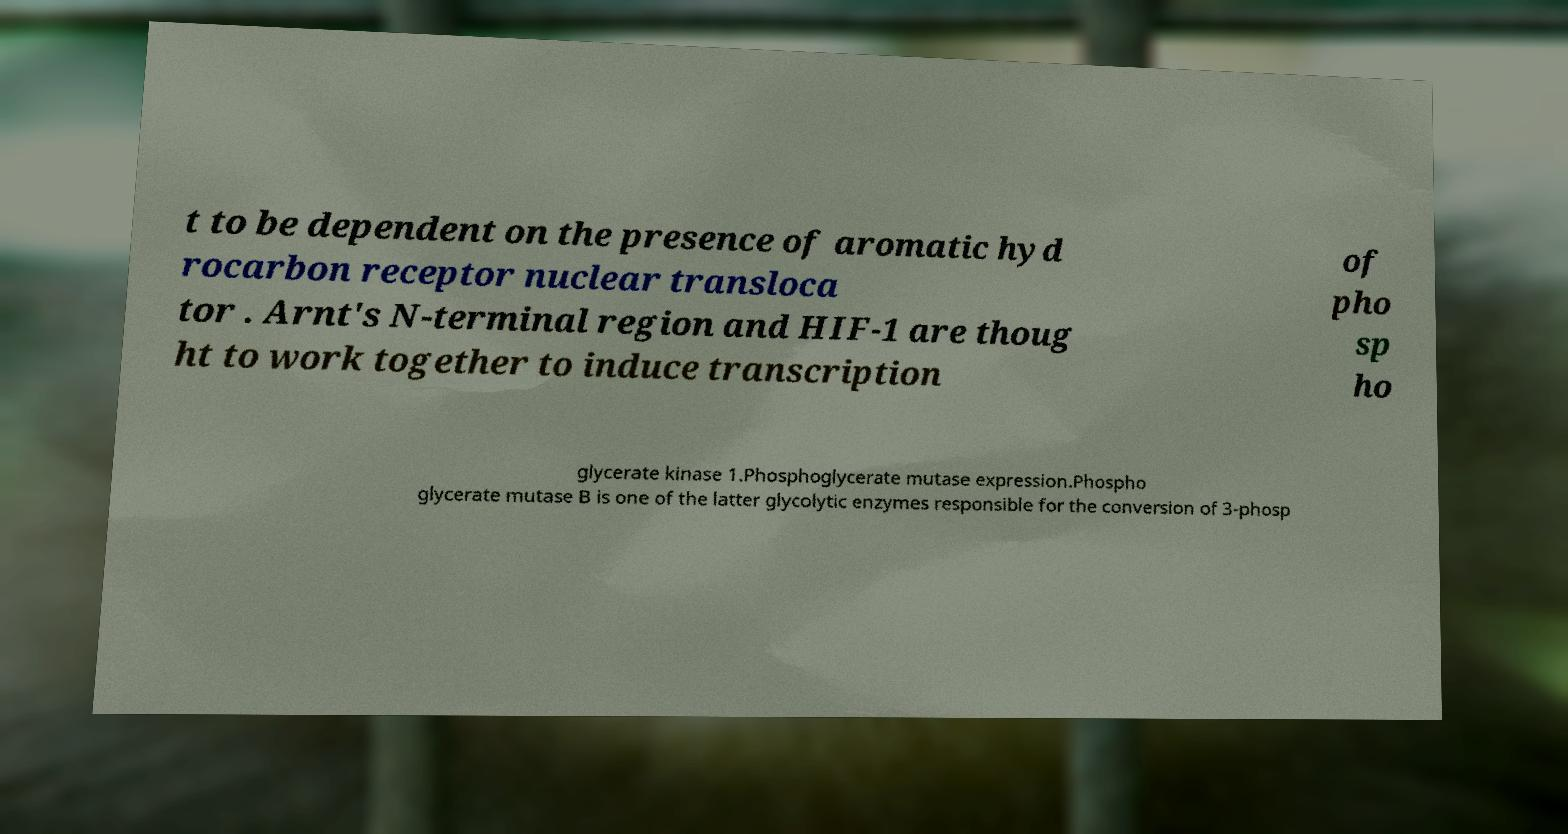For documentation purposes, I need the text within this image transcribed. Could you provide that? t to be dependent on the presence of aromatic hyd rocarbon receptor nuclear transloca tor . Arnt's N-terminal region and HIF-1 are thoug ht to work together to induce transcription of pho sp ho glycerate kinase 1.Phosphoglycerate mutase expression.Phospho glycerate mutase B is one of the latter glycolytic enzymes responsible for the conversion of 3-phosp 